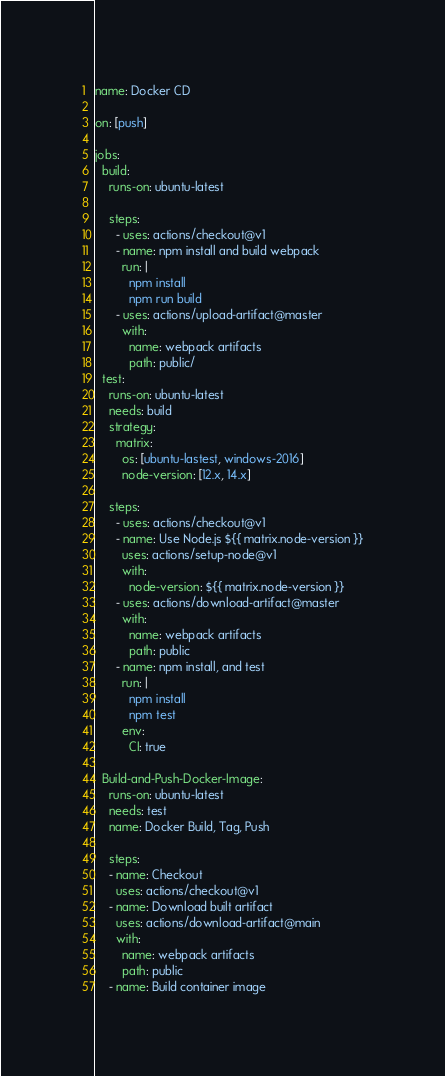Convert code to text. <code><loc_0><loc_0><loc_500><loc_500><_YAML_>name: Docker CD

on: [push]

jobs:
  build:
    runs-on: ubuntu-latest

    steps:
      - uses: actions/checkout@v1
      - name: npm install and build webpack
        run: |
          npm install
          npm run build
      - uses: actions/upload-artifact@master
        with:
          name: webpack artifacts
          path: public/
  test:
    runs-on: ubuntu-latest
    needs: build
    strategy:
      matrix:
        os: [ubuntu-lastest, windows-2016]
        node-version: [12.x, 14.x]

    steps:
      - uses: actions/checkout@v1
      - name: Use Node.js ${{ matrix.node-version }}
        uses: actions/setup-node@v1
        with:
          node-version: ${{ matrix.node-version }}
      - uses: actions/download-artifact@master
        with:
          name: webpack artifacts
          path: public
      - name: npm install, and test
        run: |
          npm install
          npm test
        env:
          CI: true

  Build-and-Push-Docker-Image:
    runs-on: ubuntu-latest
    needs: test
    name: Docker Build, Tag, Push

    steps:
    - name: Checkout
      uses: actions/checkout@v1
    - name: Download built artifact
      uses: actions/download-artifact@main
      with:
        name: webpack artifacts
        path: public
    - name: Build container image</code> 